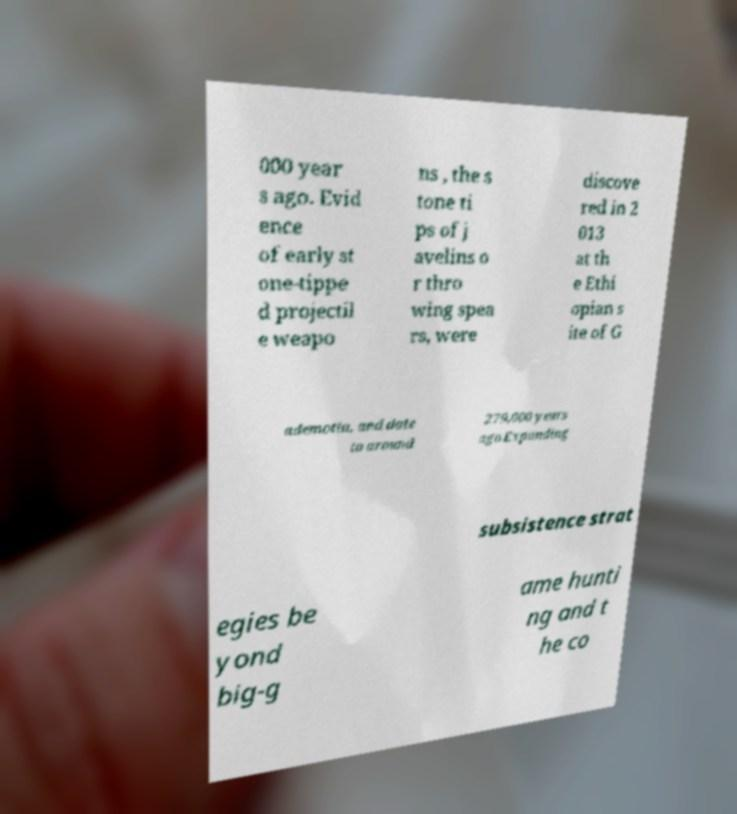What messages or text are displayed in this image? I need them in a readable, typed format. 000 year s ago. Evid ence of early st one-tippe d projectil e weapo ns , the s tone ti ps of j avelins o r thro wing spea rs, were discove red in 2 013 at th e Ethi opian s ite of G ademotta, and date to around 279,000 years ago.Expanding subsistence strat egies be yond big-g ame hunti ng and t he co 